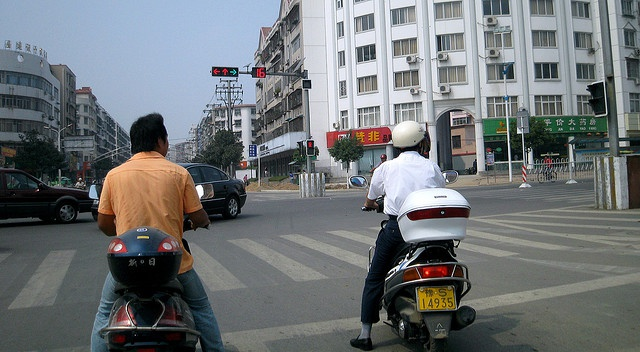Describe the objects in this image and their specific colors. I can see people in darkgray, black, tan, and gray tones, motorcycle in darkgray, black, white, and gray tones, motorcycle in darkgray, black, gray, blue, and darkblue tones, people in darkgray, black, lavender, and gray tones, and car in darkgray, black, and purple tones in this image. 